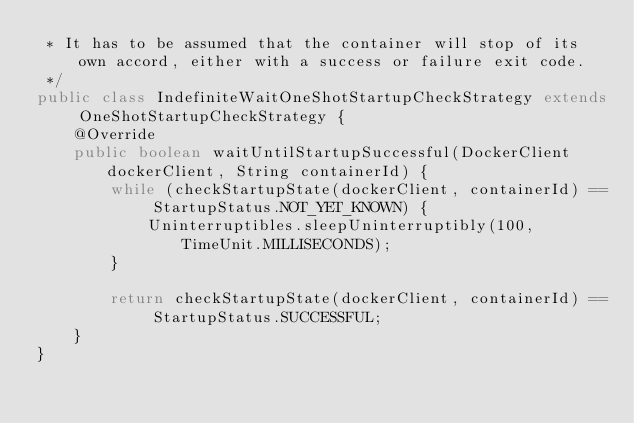Convert code to text. <code><loc_0><loc_0><loc_500><loc_500><_Java_> * It has to be assumed that the container will stop of its own accord, either with a success or failure exit code.
 */
public class IndefiniteWaitOneShotStartupCheckStrategy extends OneShotStartupCheckStrategy {
    @Override
    public boolean waitUntilStartupSuccessful(DockerClient dockerClient, String containerId) {
        while (checkStartupState(dockerClient, containerId) == StartupStatus.NOT_YET_KNOWN) {
            Uninterruptibles.sleepUninterruptibly(100, TimeUnit.MILLISECONDS);
        }

        return checkStartupState(dockerClient, containerId) == StartupStatus.SUCCESSFUL;
    }
}
</code> 